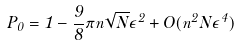<formula> <loc_0><loc_0><loc_500><loc_500>P _ { 0 } = 1 - \frac { 9 } { 8 } \pi n \sqrt { N } { \epsilon } ^ { 2 } + O ( n ^ { 2 } N { \epsilon } ^ { 4 } )</formula> 